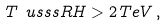Convert formula to latex. <formula><loc_0><loc_0><loc_500><loc_500>T _ { \ } u s s s R H > 2 \, T e V \, ,</formula> 